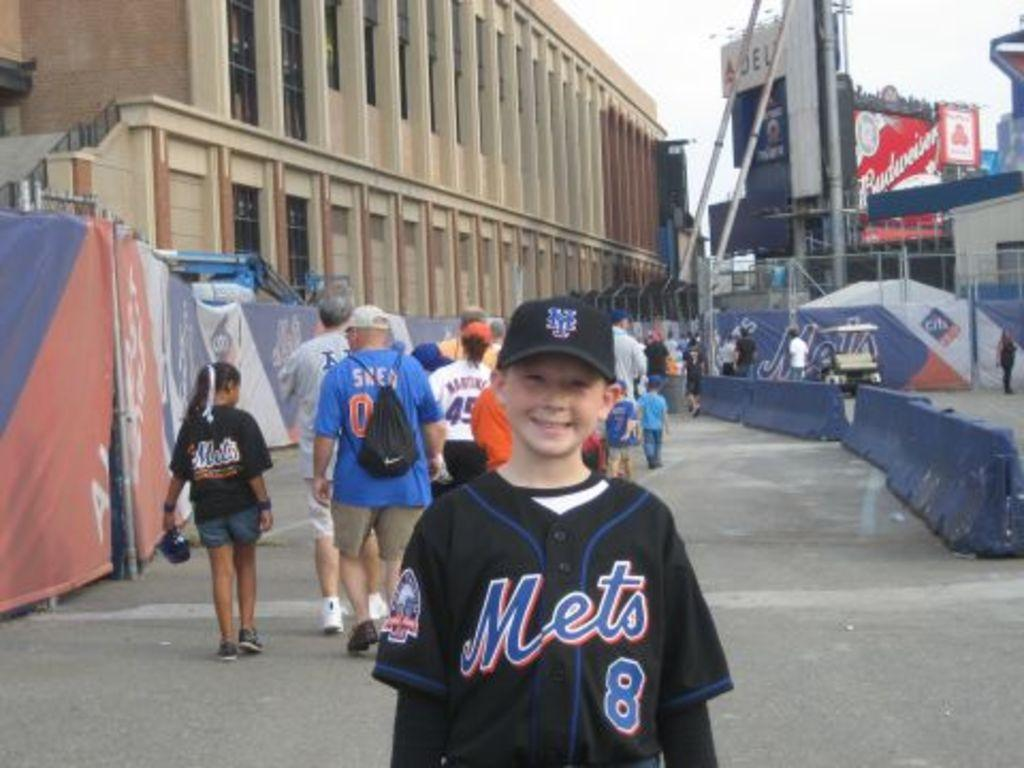<image>
Give a short and clear explanation of the subsequent image. A boy wearing a Mets jersey smiles for the camera. 